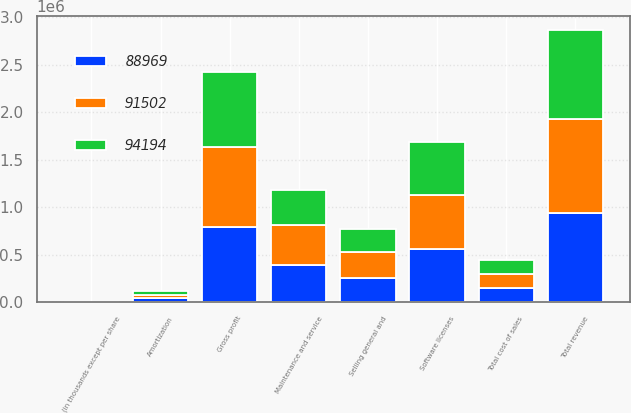Convert chart to OTSL. <chart><loc_0><loc_0><loc_500><loc_500><stacked_bar_chart><ecel><fcel>(in thousands except per share<fcel>Software licenses<fcel>Maintenance and service<fcel>Total revenue<fcel>Amortization<fcel>Total cost of sales<fcel>Gross profit<fcel>Selling general and<nl><fcel>91502<fcel>2016<fcel>568174<fcel>420291<fcel>988465<fcel>38092<fcel>146860<fcel>841605<fcel>269515<nl><fcel>88969<fcel>2015<fcel>555105<fcel>387648<fcel>942753<fcel>38755<fcel>147246<fcel>795507<fcel>253603<nl><fcel>94194<fcel>2014<fcel>564502<fcel>371519<fcel>936021<fcel>37653<fcel>153386<fcel>782635<fcel>246376<nl></chart> 